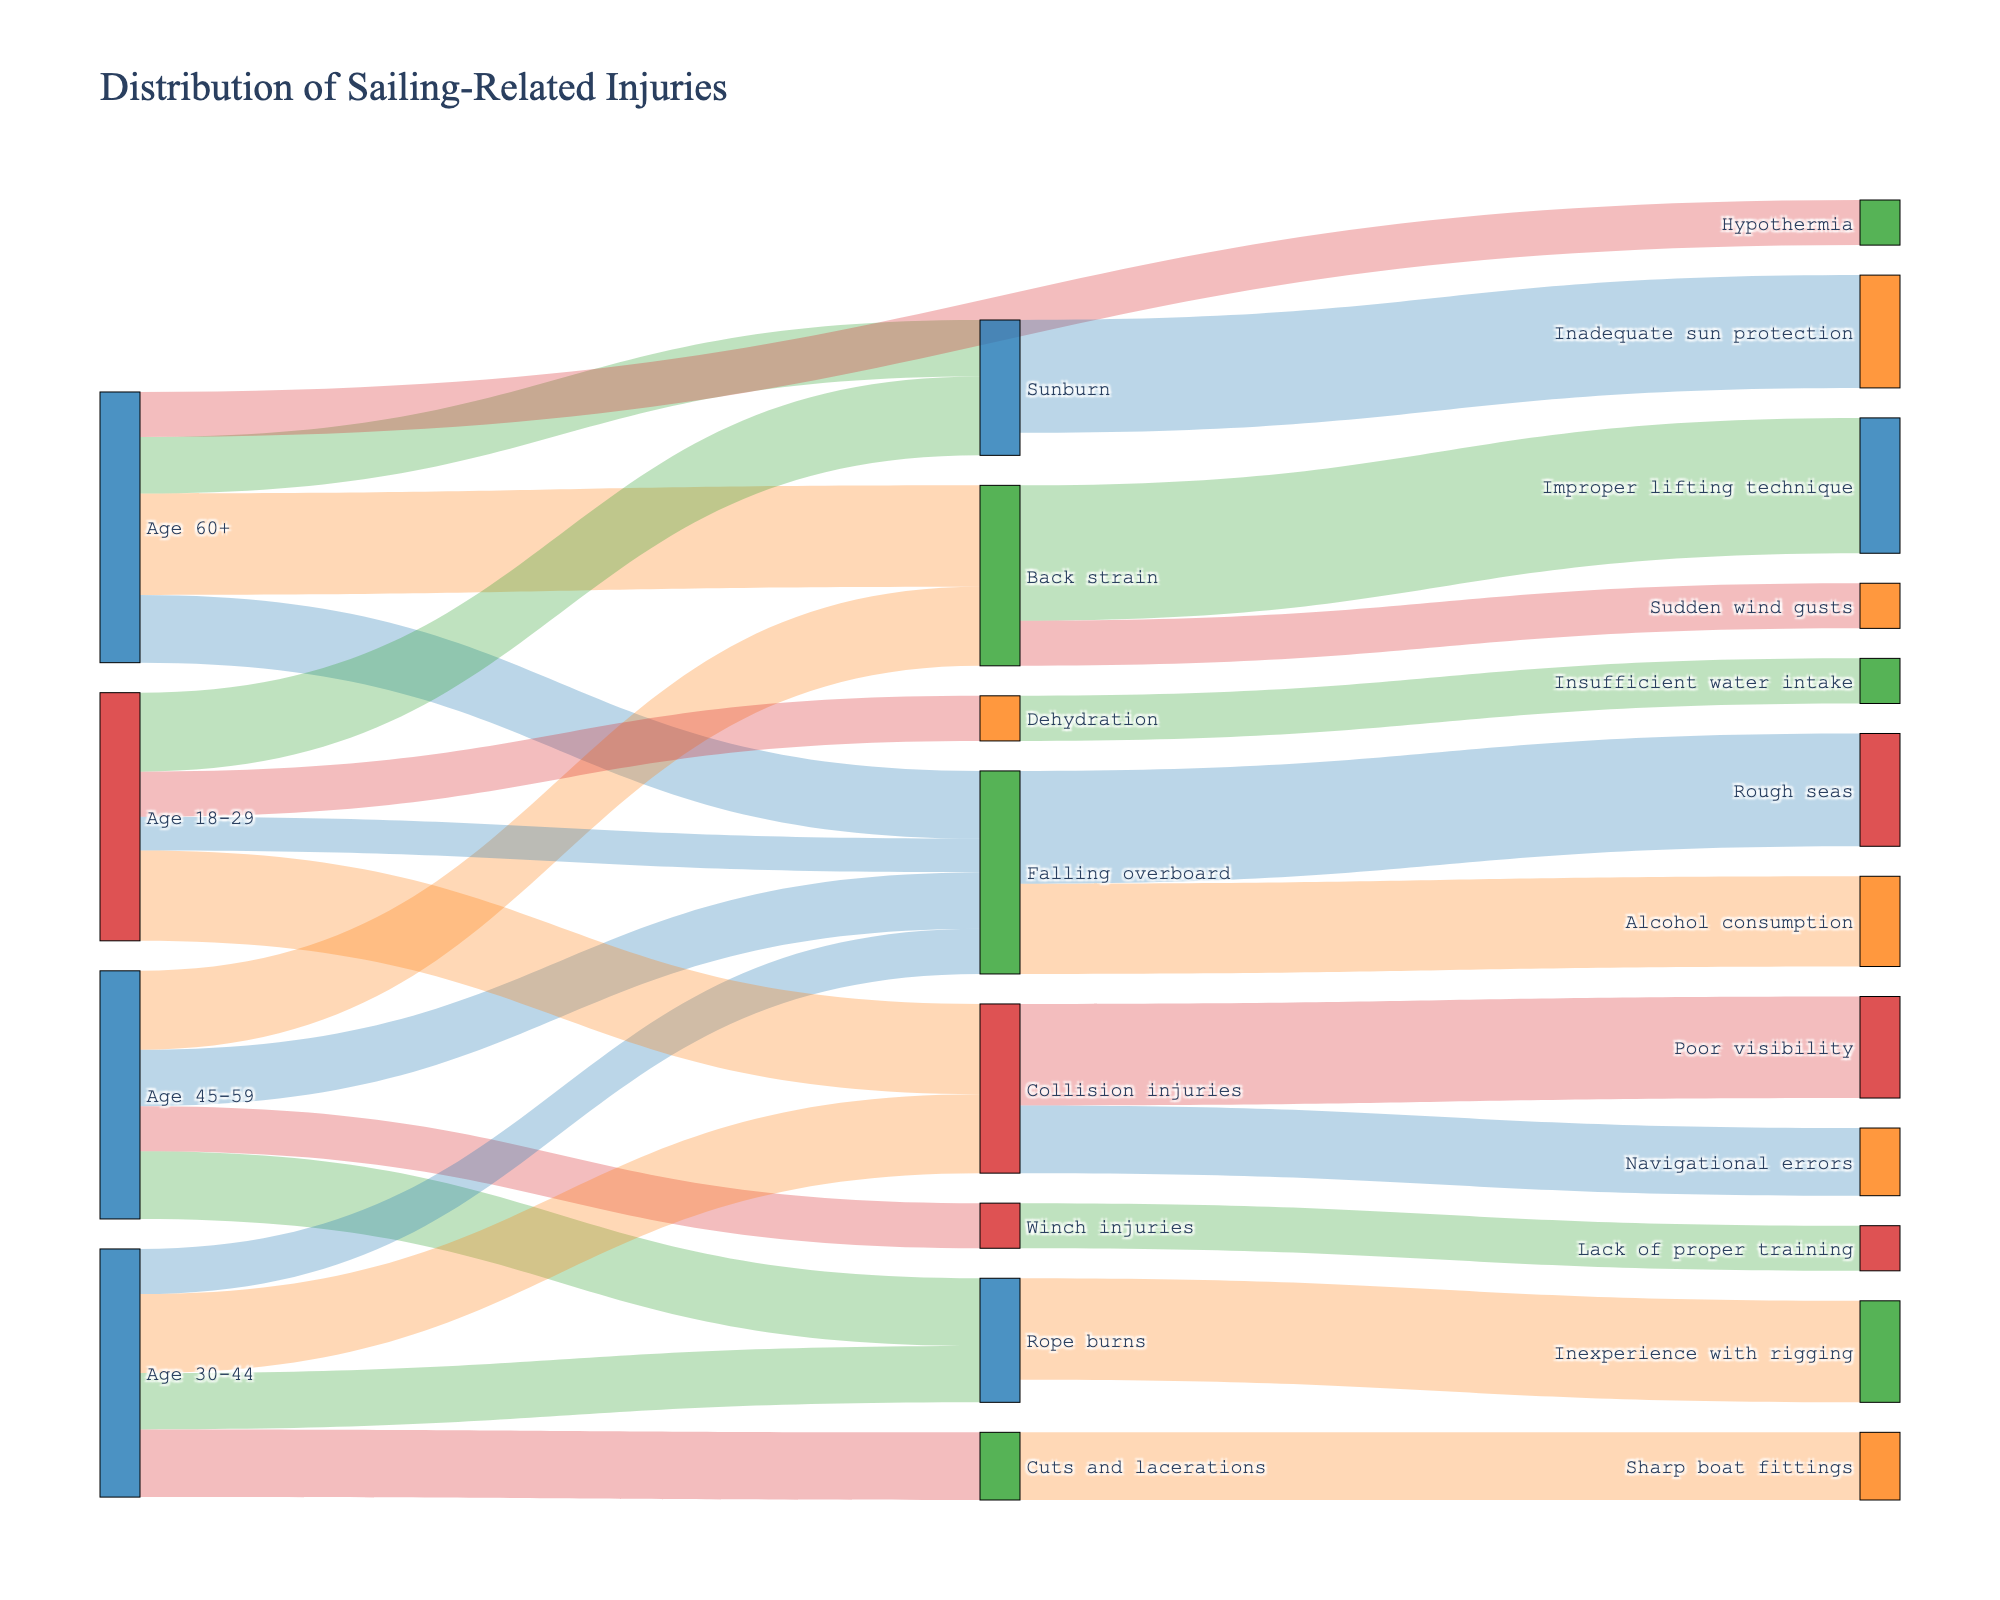How many injuries are listed under the age group 18-29? There are four injuries listed for the age group 18-29: Falling overboard, Collision injuries, Sunburn, and Dehydration. Counting their occurrences, we get 4.
Answer: 4 Which cause is responsible for the highest number of "Falling overboard" injuries? By examining the figure, we see that Falling overboard is caused by Rough seas and Alcohol consumption. Rough seas have a value of 50, which is higher than Alcohol consumption.
Answer: Rough seas What is the total number of injuries caused by "Collision injuries"? Checking the targets of Collision injuries, we find Poor visibility (45) and Navigational errors (30). Adding these values, the total is 45 + 30 = 75.
Answer: 75 Are there more "Back strain" injuries due to Improper lifting technique or Sudden wind gusts? Back strain is caused by Improper lifting technique (60) and Sudden wind gusts (20). Comparing these values, Improper lifting technique has more injuries.
Answer: Improper lifting technique What's the total number of injuries in the age group 30-44? The injuries in the age group 30-44 are Falling overboard (20), Collision injuries (35), Rope burns (25), and Cuts and lacerations (30). Summing these values gives 20 + 35 + 25 + 30 = 110.
Answer: 110 Which age group has the highest number of "Sunburn" injuries? There are two age groups with Sunburn injuries: Age 60+ (25) and Age 18-29 (35). The age group 18-29 has the higher number of injuries.
Answer: Age 18-29 How many injuries are in the "Rope burns" category? The "Rope burns" category has 25 injuries in the age 30-44 group and 30 in the age 45-59 group. Summing these values gives 25 + 30 = 55.
Answer: 55 What is the cause of the least number of injuries in "Back strain"? Examining the causes of Back strain, we see Improper lifting technique (60) and Sudden wind gusts (20). Sudden wind gusts have the least number of injuries.
Answer: Sudden wind gusts Which age group has more "Falling overboard" injuries, Age 18-29 or Age 45-59? Falling overboard injuries for Age 18-29 are 15, and for Age 45-59 are 25. Age 45-59 has more Falling overboard injuries.
Answer: Age 45-59 